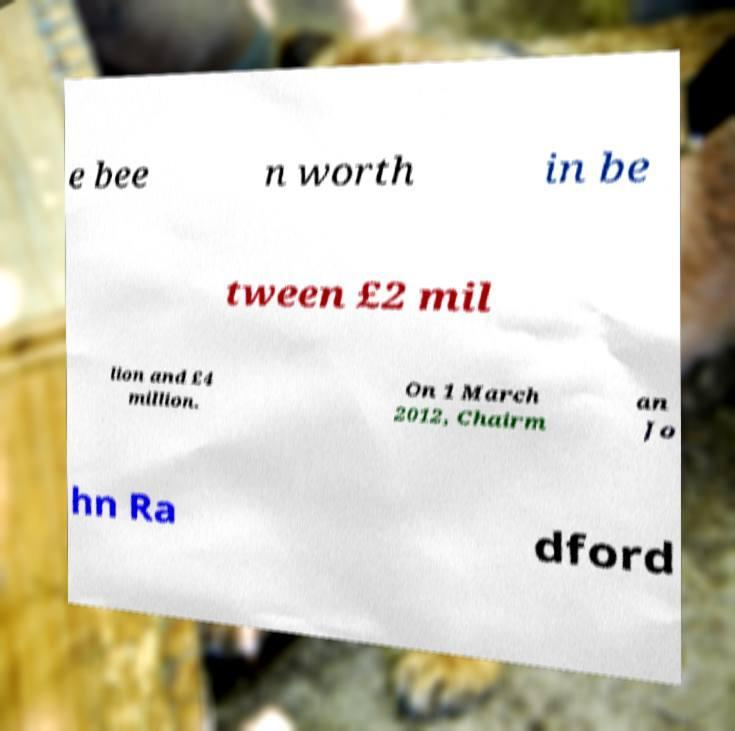Can you read and provide the text displayed in the image?This photo seems to have some interesting text. Can you extract and type it out for me? e bee n worth in be tween £2 mil lion and £4 million. On 1 March 2012, Chairm an Jo hn Ra dford 